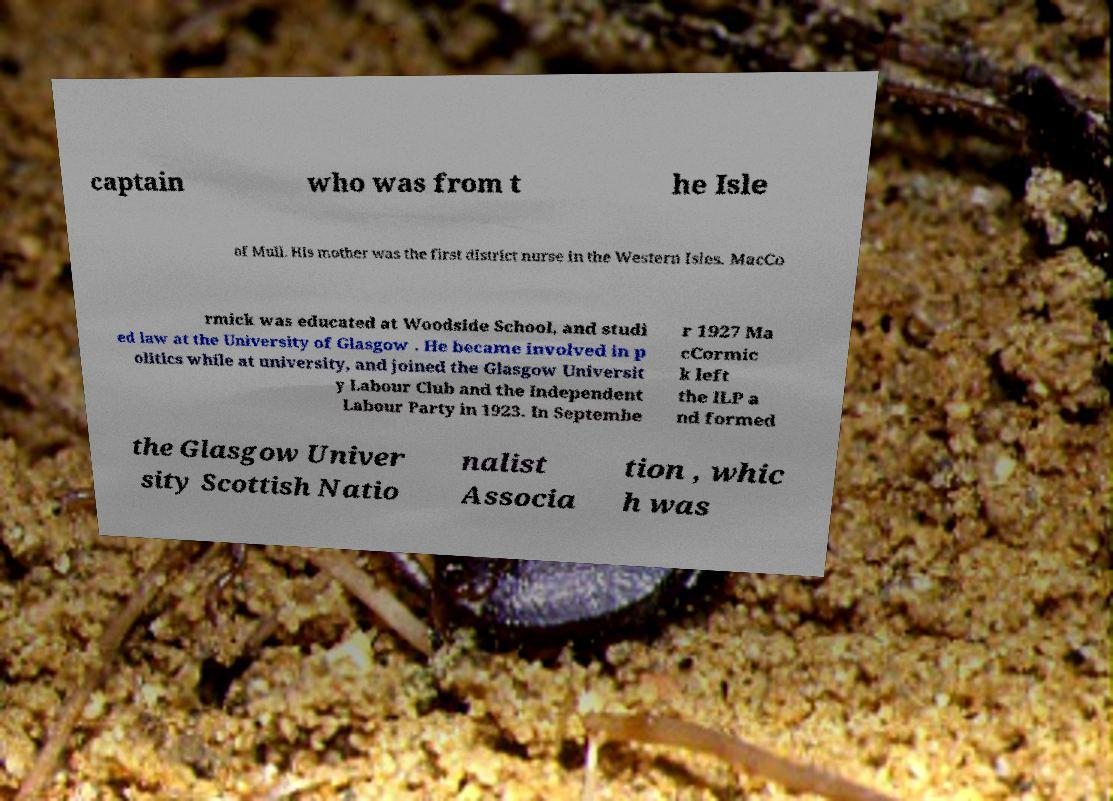Can you read and provide the text displayed in the image?This photo seems to have some interesting text. Can you extract and type it out for me? captain who was from t he Isle of Mull. His mother was the first district nurse in the Western Isles. MacCo rmick was educated at Woodside School, and studi ed law at the University of Glasgow . He became involved in p olitics while at university, and joined the Glasgow Universit y Labour Club and the Independent Labour Party in 1923. In Septembe r 1927 Ma cCormic k left the ILP a nd formed the Glasgow Univer sity Scottish Natio nalist Associa tion , whic h was 